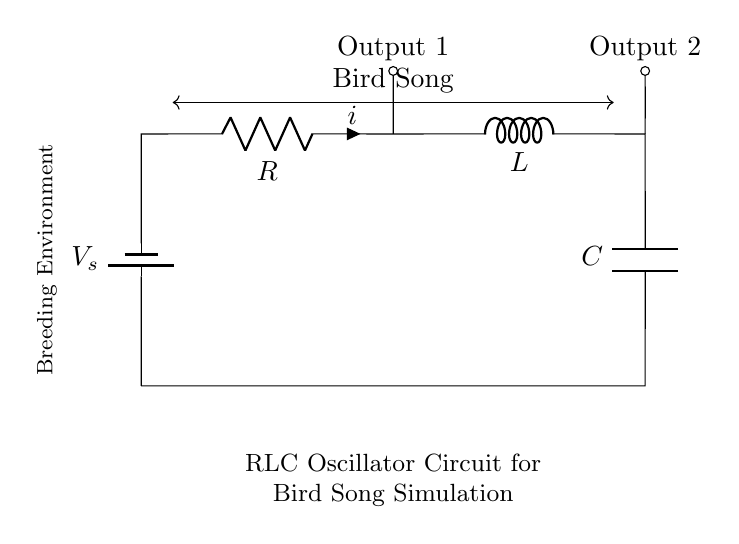What are the components in this circuit? The circuit includes a resistor, inductor, capacitor, and a battery. These components are indicated in the diagram as R, L, C, and V_s respectively.
Answer: Resistor, Inductor, Capacitor, Battery What type of circuit is shown here? This is an RLC oscillator circuit, which is evidenced by the presence of a resistor, inductor, and capacitor arranged in a closed loop. The circuit diagram specifically labels it as an RLC Oscillator.
Answer: RLC oscillator What does the symbol V_s represent? V_s stands for the supply voltage from the battery, which powers the circuit. In the diagram, it is labeled as the voltage source connected at the top of the circuit.
Answer: Supply voltage How many outputs are indicated in the circuit? The diagram shows two outputs, which are labeled Output 1 and Output 2. These are connected to the circuit at different points.
Answer: Two outputs What type of signal is generated by this circuit in a breeding environment? The circuit is designed to simulate bird songs, as indicated by the arrow between the components and the text labeling the signal in the diagram.
Answer: Bird song Which component is responsible for storing energy in this circuit? The capacitor is responsible for storing energy, as indicated by its presence in the circuit and its function in an RLC circuit, where it temporarily holds electrical charge.
Answer: Capacitor 